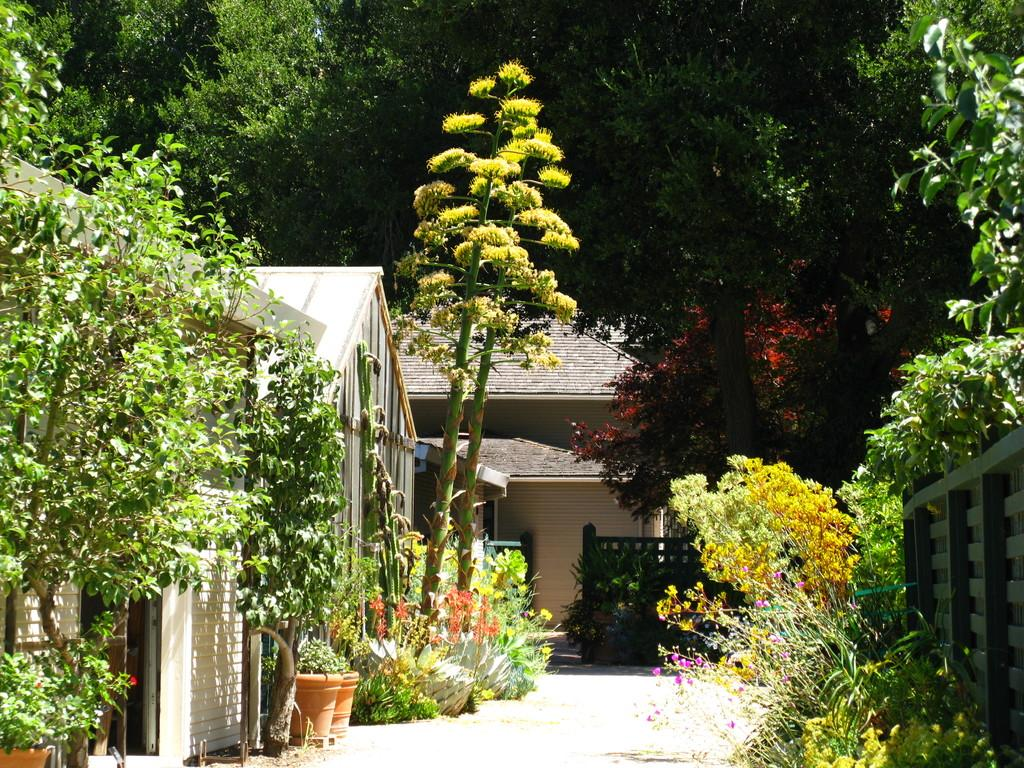What type of structures can be seen in the foreground of the image? There are houses in the foreground of the image. What is located on the right side of the image? There is a railing on the right side of the image. What type of plants are at the bottom of the image? There are flower plants at the bottom of the image. What can be seen in the background of the image? There is greenery in the background of the image. How does the angle of the image affect the comfort of the houses in the foreground? The angle of the image does not affect the comfort of the houses in the foreground, as it is a static image and not a representation of the actual living conditions. 